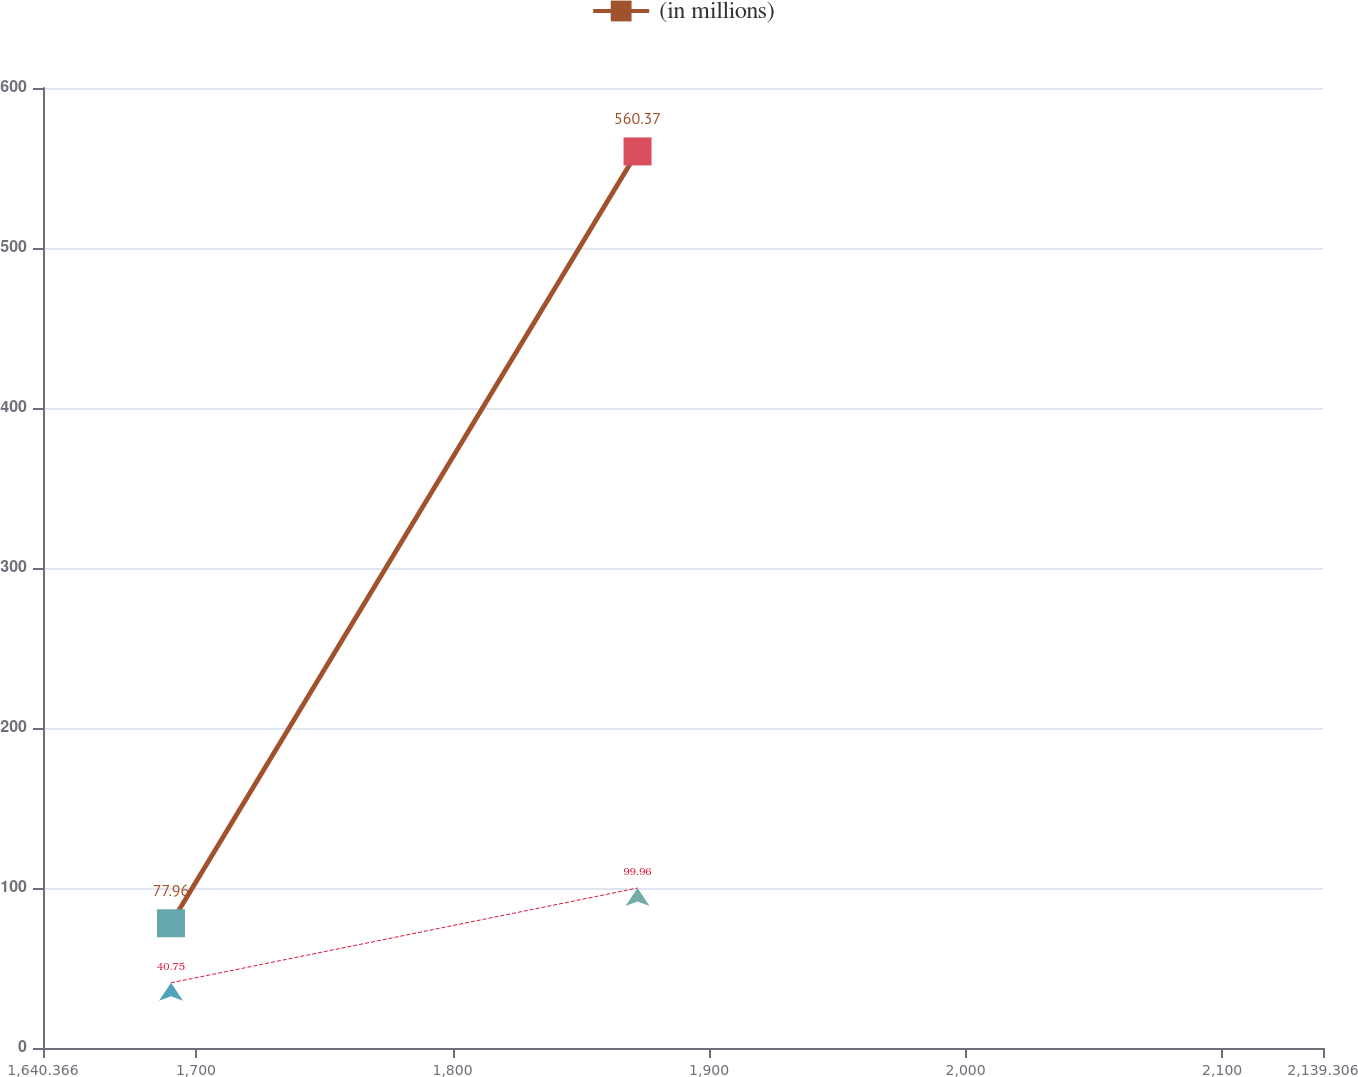Convert chart to OTSL. <chart><loc_0><loc_0><loc_500><loc_500><line_chart><ecel><fcel>Unnamed: 1<fcel>(in millions)<nl><fcel>1690.26<fcel>40.75<fcel>77.96<nl><fcel>1872.12<fcel>99.96<fcel>560.37<nl><fcel>2189.2<fcel>50.73<fcel>213.8<nl></chart> 